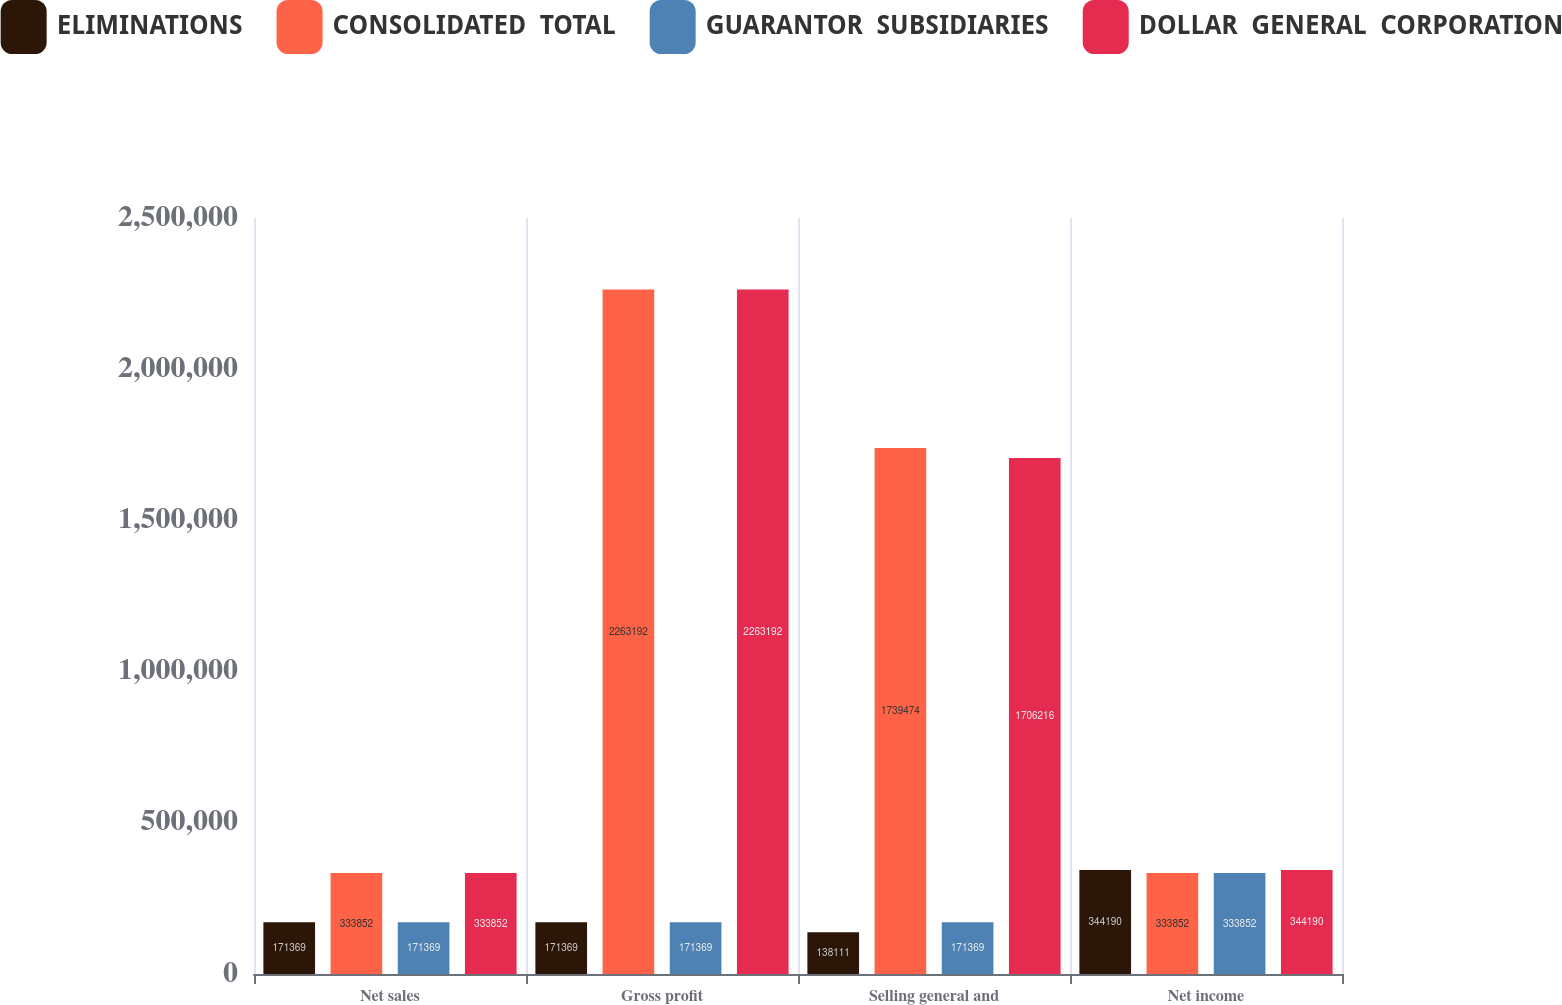Convert chart to OTSL. <chart><loc_0><loc_0><loc_500><loc_500><stacked_bar_chart><ecel><fcel>Net sales<fcel>Gross profit<fcel>Selling general and<fcel>Net income<nl><fcel>ELIMINATIONS<fcel>171369<fcel>171369<fcel>138111<fcel>344190<nl><fcel>CONSOLIDATED  TOTAL<fcel>333852<fcel>2.26319e+06<fcel>1.73947e+06<fcel>333852<nl><fcel>GUARANTOR  SUBSIDIARIES<fcel>171369<fcel>171369<fcel>171369<fcel>333852<nl><fcel>DOLLAR  GENERAL  CORPORATION<fcel>333852<fcel>2.26319e+06<fcel>1.70622e+06<fcel>344190<nl></chart> 